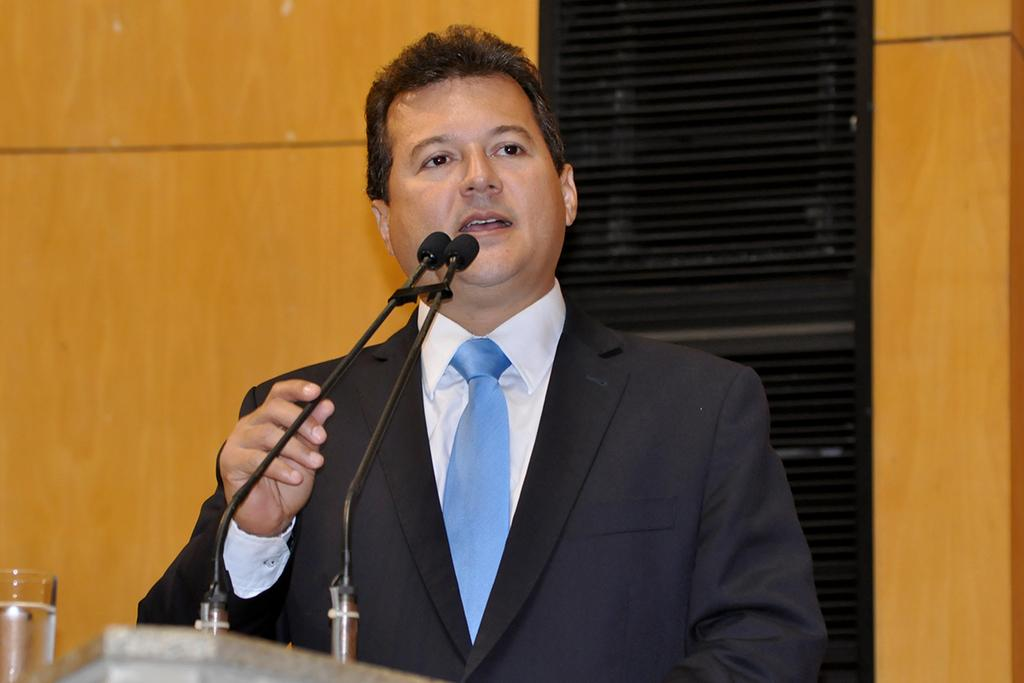What color is the wall visible in the image? The wall in the image is yellow. Who or what can be seen in front of the wall? A man is standing in front of the wall. What object is in front of the man? There is a microphone (mike) in front of the man. What type of condition does the man have with the spiders in the image? There are no spiders present in the image, so the man's condition with spiders cannot be determined. Can you describe the kiss between the man and the microphone in the image? There is no kiss between the man and the microphone in the image; the man is simply standing in front of it. 